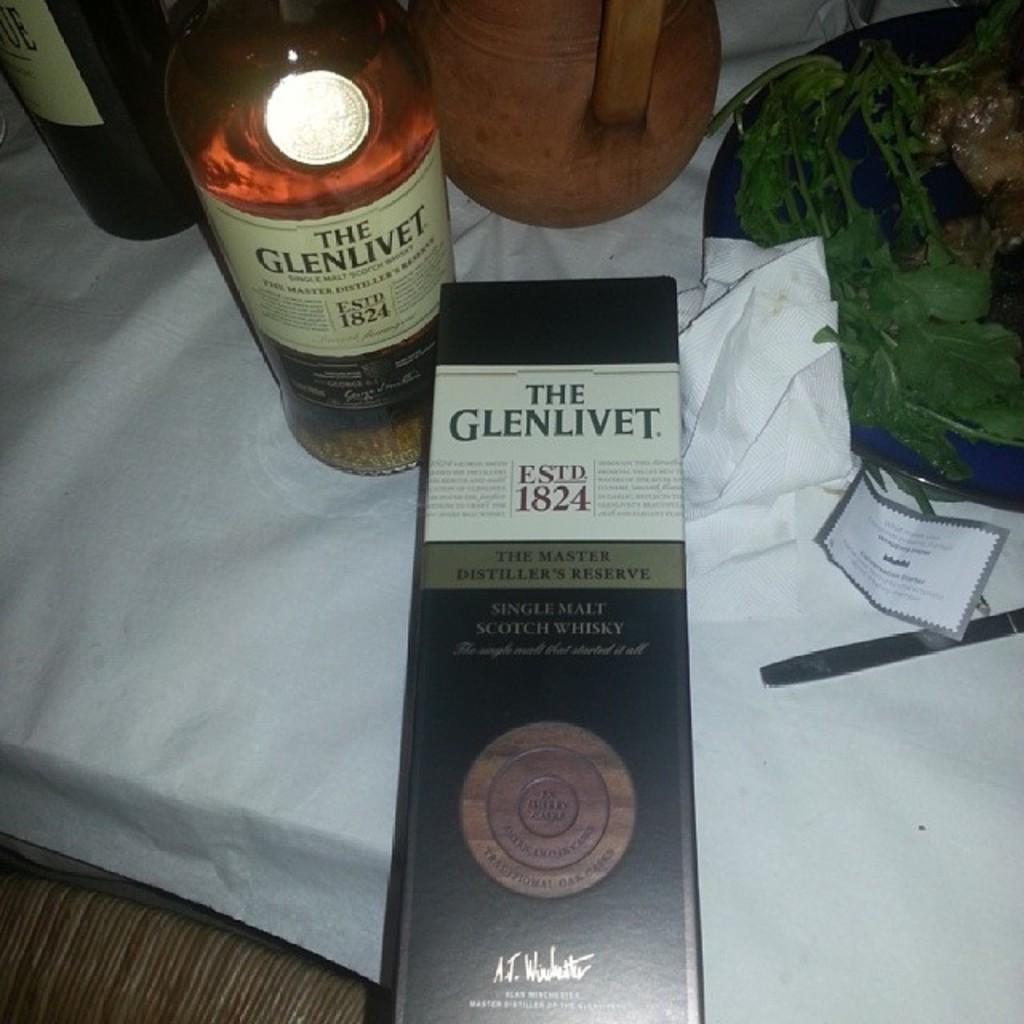<image>
Render a clear and concise summary of the photo. A Glenlivet bottle sits on a white table cloth. 